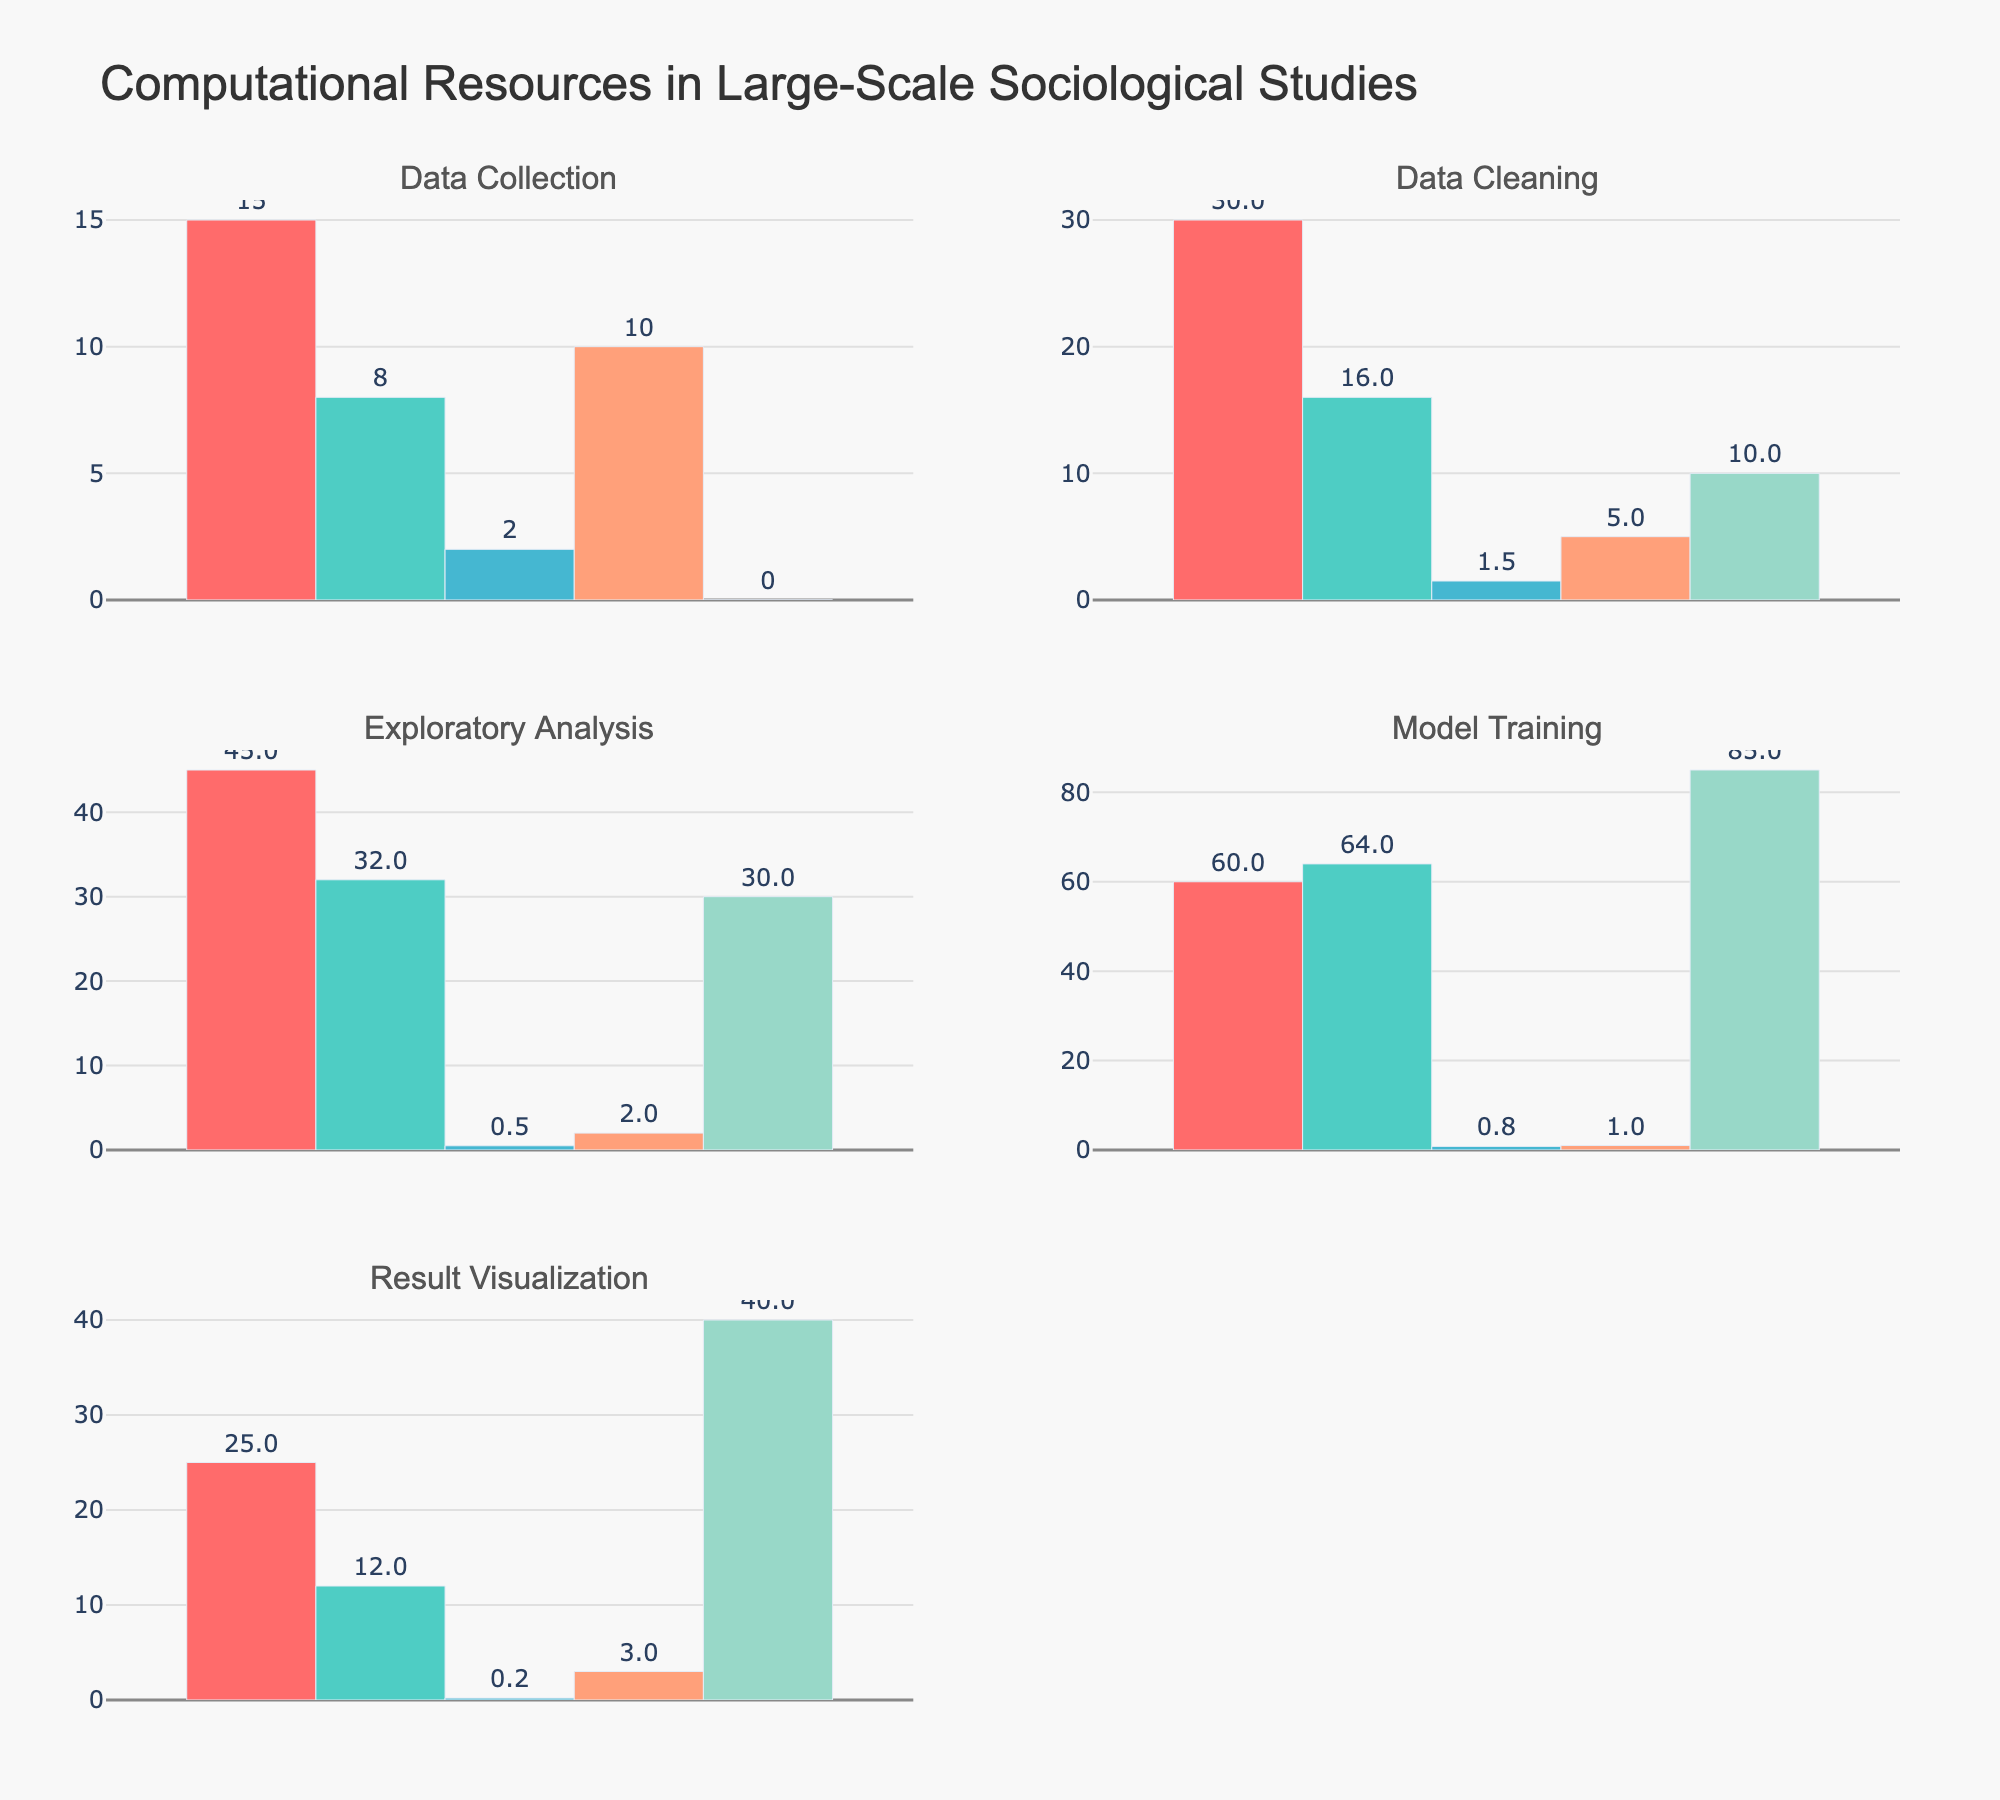what is the title of the figure? The title is located at the top of the figure and provides a summary of what the figure is about. In this case, it states "Computational Resources in Large-Scale Sociological Studies".
Answer: "Computational Resources in Large-Scale Sociological Studies" what are the stages of data processing shown in the figure? The stages of data processing are labeled as subplot titles and include Data Collection, Data Cleaning, Exploratory Analysis, Model Training, and Result Visualization.
Answer: Data Collection, Data Cleaning, Exploratory Analysis, Model Training, Result Visualization which stage has the highest CPU Usage percentage? From the subplot on CPU Usage, it is evident that Model Training has the highest percentage at 60%.
Answer: Model Training how much RAM is used during the Exploratory Analysis stage? Referring to the RAM Usage subplot, the bar labeled Exploratory Analysis shows a value of 32 GB.
Answer: 32 GB compare the Storage Used during Data Collection and Data Cleaning stages. Which one is greater? By checking the Storage Used subplot, Data Collection has 2 TB, and Data Cleaning has 1.5 TB. Therefore, Data Collection uses more storage.
Answer: Data Collection what is the difference in Network Bandwidth utilization between Data Collection and Result Visualization? Data Collection utilizes 10 Gbps, whereas Result Visualization utilizes 3 Gbps. The difference is 10 - 3 = 7 Gbps.
Answer: 7 Gbps what is the total RAM usage across all stages? Add up the RAM usage values for all stages: 8 + 16 + 32 + 64 + 12 = 132 GB.
Answer: 132 GB what is the average GPU Utilization across all stages? Sum all GPU Utilization values: 0 + 10 + 30 + 85 + 40 = 165%. There are 5 stages, so the average is 165 / 5 = 33%.
Answer: 33% which stage has the least GPU Utilization? By observing the GPU Utilization subplot, the Data Collection stage has the least GPU Utilization at 0%.
Answer: Data Collection how does the CPU Usage in Data Cleaning compare to that in Result Visualization? From the CPU Usage subplot, Data Cleaning has a value of 30%, and Result Visualization has 25%. Therefore, Data Cleaning has a higher CPU Usage by 5%.
Answer: Data Cleaning 